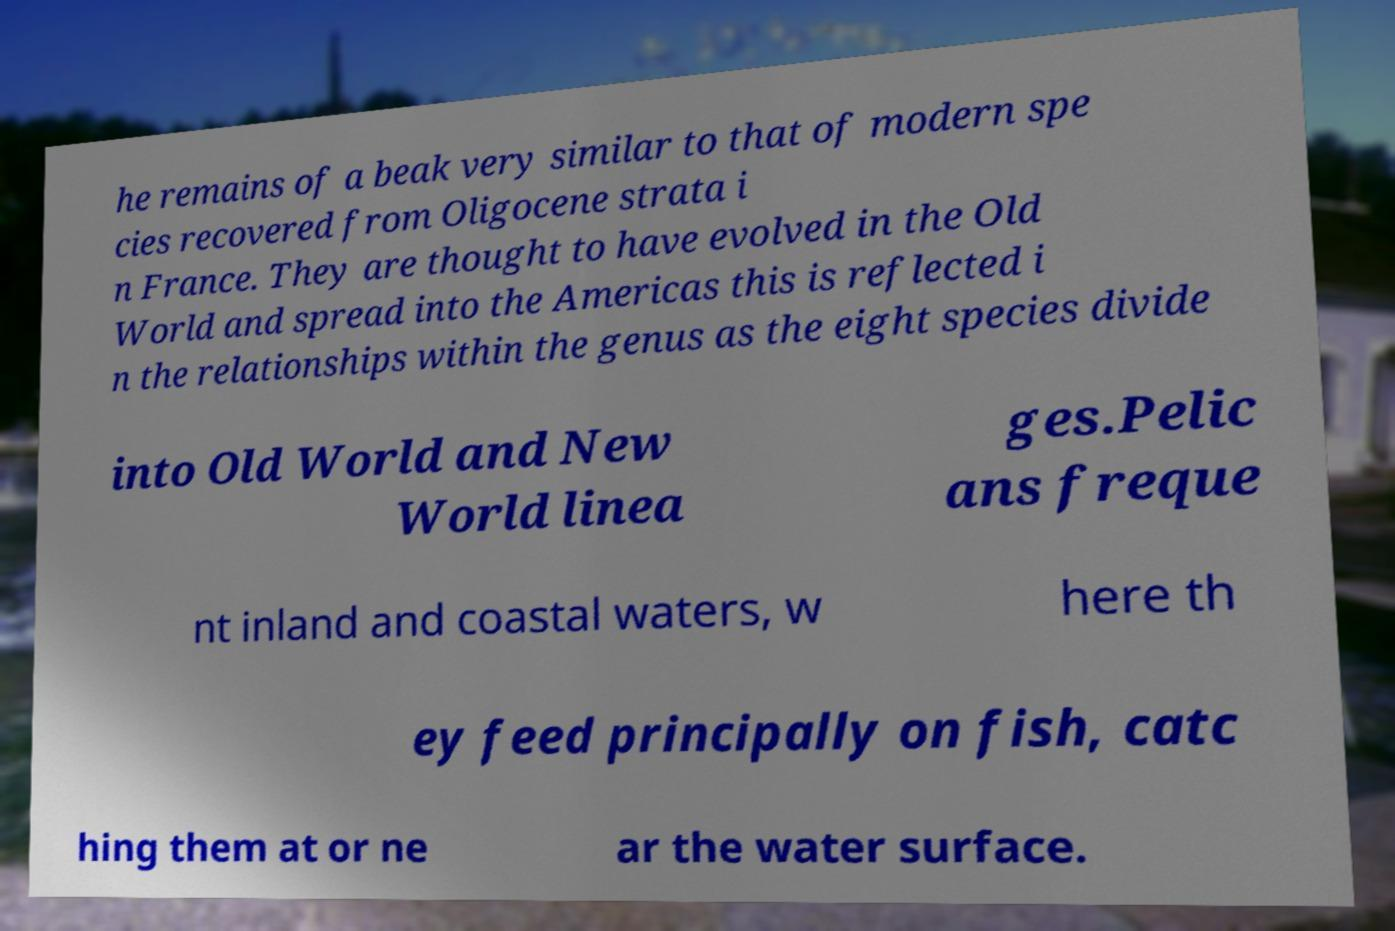What messages or text are displayed in this image? I need them in a readable, typed format. he remains of a beak very similar to that of modern spe cies recovered from Oligocene strata i n France. They are thought to have evolved in the Old World and spread into the Americas this is reflected i n the relationships within the genus as the eight species divide into Old World and New World linea ges.Pelic ans freque nt inland and coastal waters, w here th ey feed principally on fish, catc hing them at or ne ar the water surface. 